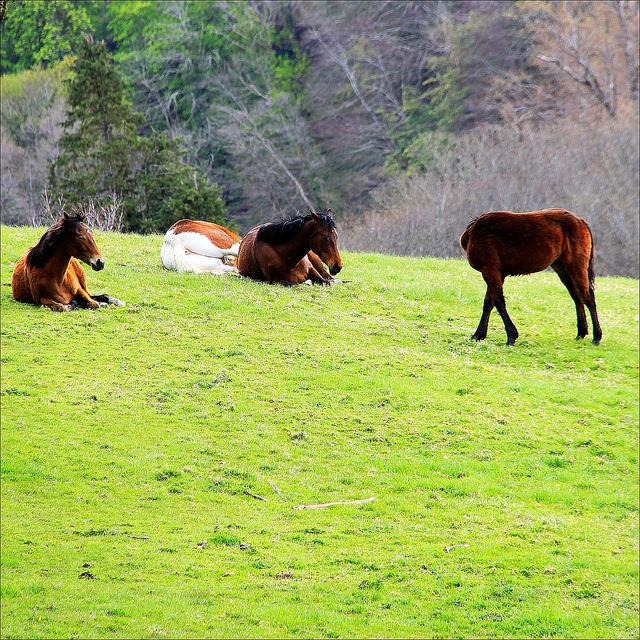Are the trees blooming?
Give a very brief answer. No. Are the horses wild?
Concise answer only. Yes. Are these horses mating?
Write a very short answer. No. Are the horses tired?
Be succinct. Yes. 